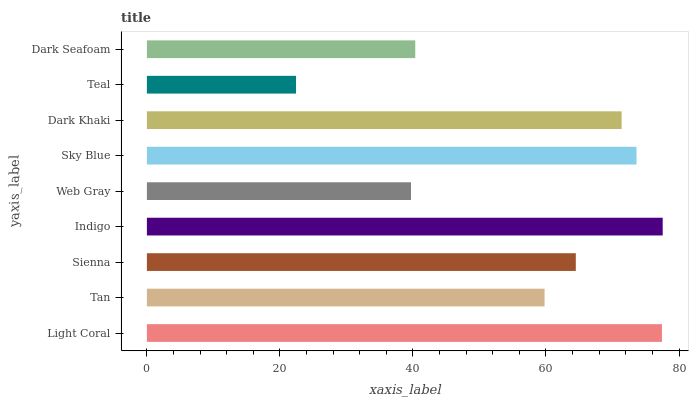Is Teal the minimum?
Answer yes or no. Yes. Is Indigo the maximum?
Answer yes or no. Yes. Is Tan the minimum?
Answer yes or no. No. Is Tan the maximum?
Answer yes or no. No. Is Light Coral greater than Tan?
Answer yes or no. Yes. Is Tan less than Light Coral?
Answer yes or no. Yes. Is Tan greater than Light Coral?
Answer yes or no. No. Is Light Coral less than Tan?
Answer yes or no. No. Is Sienna the high median?
Answer yes or no. Yes. Is Sienna the low median?
Answer yes or no. Yes. Is Light Coral the high median?
Answer yes or no. No. Is Sky Blue the low median?
Answer yes or no. No. 